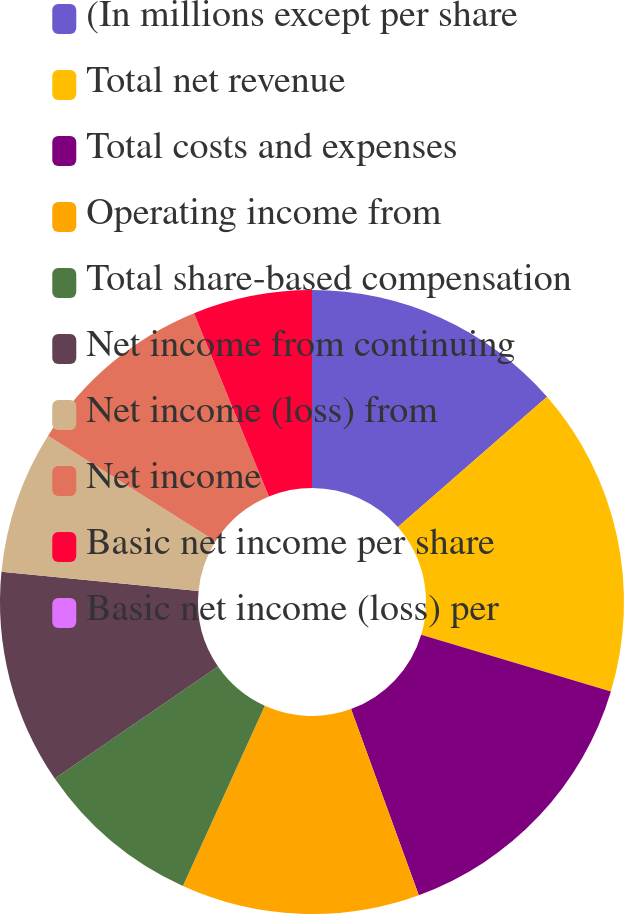Convert chart to OTSL. <chart><loc_0><loc_0><loc_500><loc_500><pie_chart><fcel>(In millions except per share<fcel>Total net revenue<fcel>Total costs and expenses<fcel>Operating income from<fcel>Total share-based compensation<fcel>Net income from continuing<fcel>Net income (loss) from<fcel>Net income<fcel>Basic net income per share<fcel>Basic net income (loss) per<nl><fcel>13.58%<fcel>16.05%<fcel>14.81%<fcel>12.35%<fcel>8.64%<fcel>11.11%<fcel>7.41%<fcel>9.88%<fcel>6.17%<fcel>0.0%<nl></chart> 